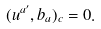<formula> <loc_0><loc_0><loc_500><loc_500>( u ^ { a ^ { \prime } } , b _ { a } ) _ { c } = 0 .</formula> 